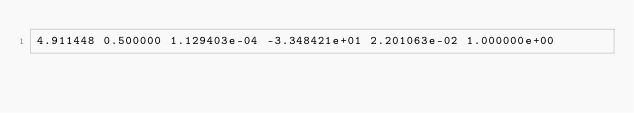<code> <loc_0><loc_0><loc_500><loc_500><_SQL_>4.911448 0.500000 1.129403e-04 -3.348421e+01 2.201063e-02 1.000000e+00 </code> 